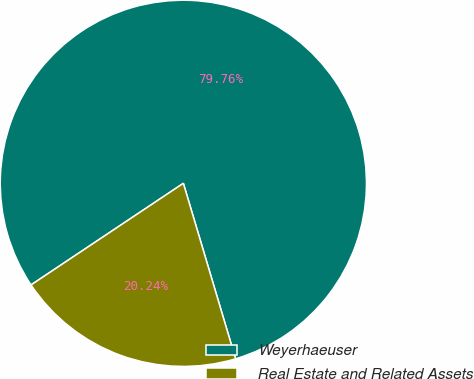<chart> <loc_0><loc_0><loc_500><loc_500><pie_chart><fcel>Weyerhaeuser<fcel>Real Estate and Related Assets<nl><fcel>79.76%<fcel>20.24%<nl></chart> 